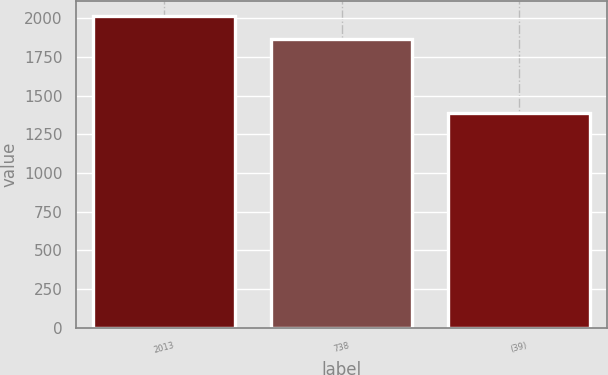Convert chart. <chart><loc_0><loc_0><loc_500><loc_500><bar_chart><fcel>2013<fcel>738<fcel>(39)<nl><fcel>2011<fcel>1863<fcel>1385<nl></chart> 